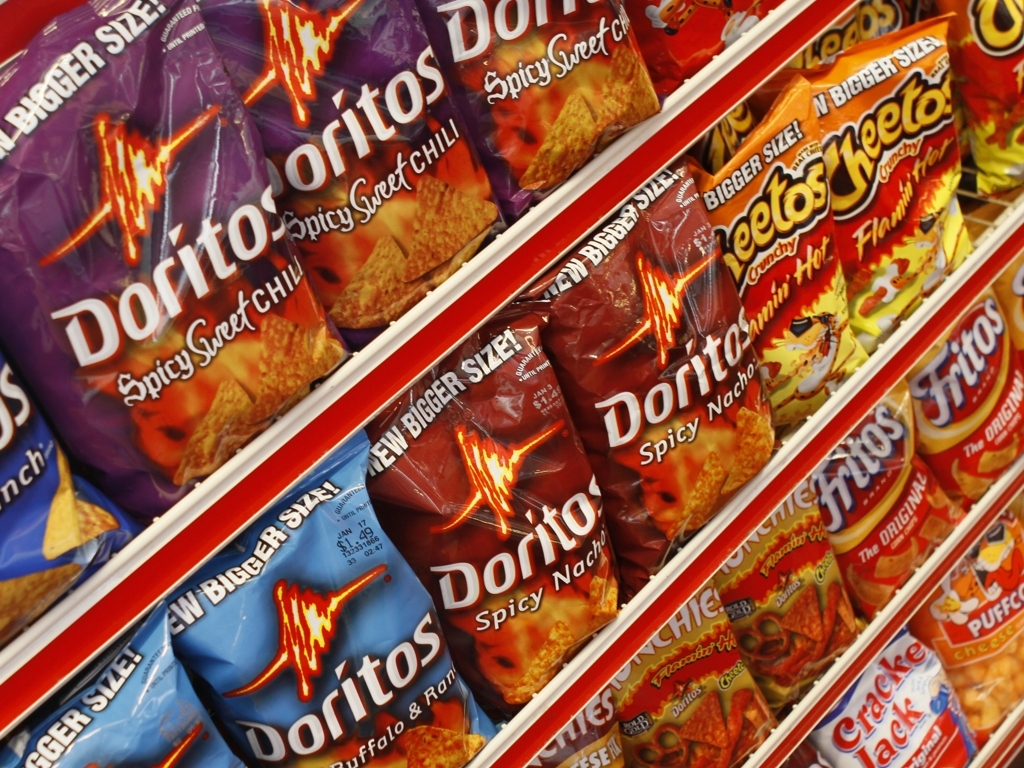How does the branding of different snack bags use color to attract attention? The branding employs bold and contrasting colors to draw the eye. Doritos, for example, uses fiery reds and intense purples to convey the spiciness of its flavors. The colors are also thematically consistent, using warm tones to suggest heat and flavor intensity. 